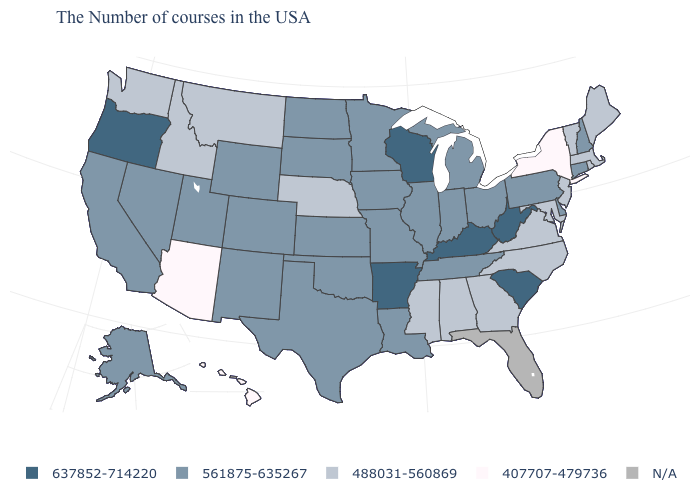What is the lowest value in the West?
Keep it brief. 407707-479736. Which states have the lowest value in the USA?
Write a very short answer. New York, Arizona, Hawaii. Name the states that have a value in the range 407707-479736?
Keep it brief. New York, Arizona, Hawaii. What is the highest value in the USA?
Concise answer only. 637852-714220. What is the value of Virginia?
Be succinct. 488031-560869. What is the value of Oklahoma?
Keep it brief. 561875-635267. What is the highest value in the South ?
Give a very brief answer. 637852-714220. Does the first symbol in the legend represent the smallest category?
Write a very short answer. No. Does Massachusetts have the highest value in the Northeast?
Write a very short answer. No. What is the value of Oregon?
Short answer required. 637852-714220. What is the value of New Hampshire?
Give a very brief answer. 561875-635267. How many symbols are there in the legend?
Short answer required. 5. Is the legend a continuous bar?
Be succinct. No. What is the lowest value in the South?
Short answer required. 488031-560869. What is the value of New Hampshire?
Quick response, please. 561875-635267. 